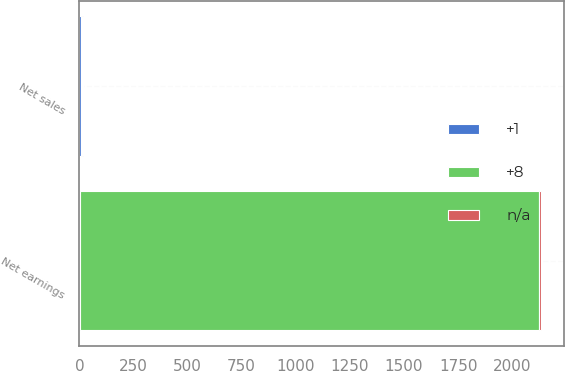Convert chart to OTSL. <chart><loc_0><loc_0><loc_500><loc_500><stacked_bar_chart><ecel><fcel>Net sales<fcel>Net earnings<nl><fcel>8<fcel>6<fcel>2123<nl><fcel>nan<fcel>6<fcel>7<nl><fcel>1<fcel>6<fcel>3<nl></chart> 